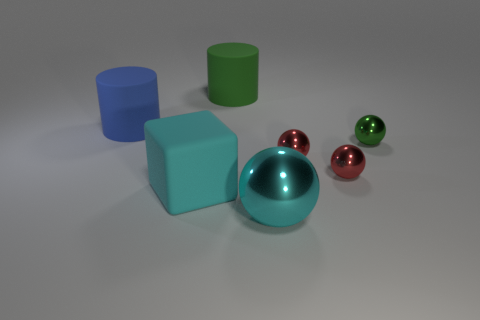Subtract 1 balls. How many balls are left? 3 Subtract all cyan metal balls. How many balls are left? 3 Subtract all cyan balls. How many balls are left? 3 Subtract all gray balls. Subtract all gray cubes. How many balls are left? 4 Add 3 tiny green spheres. How many objects exist? 10 Subtract all cubes. How many objects are left? 6 Add 4 big cubes. How many big cubes exist? 5 Subtract 1 cyan blocks. How many objects are left? 6 Subtract all large cyan matte things. Subtract all cyan matte cubes. How many objects are left? 5 Add 2 tiny green spheres. How many tiny green spheres are left? 3 